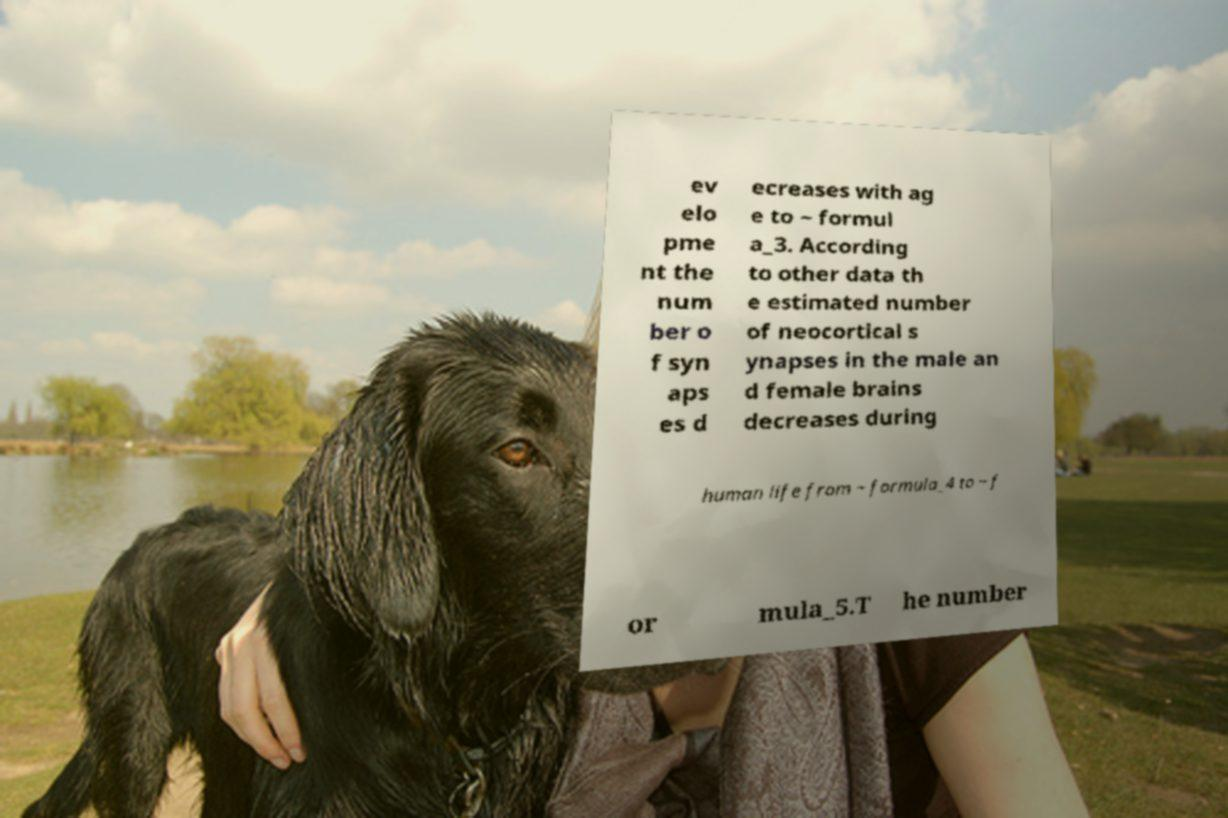Can you accurately transcribe the text from the provided image for me? ev elo pme nt the num ber o f syn aps es d ecreases with ag e to ~ formul a_3. According to other data th e estimated number of neocortical s ynapses in the male an d female brains decreases during human life from ~ formula_4 to ~ f or mula_5.T he number 